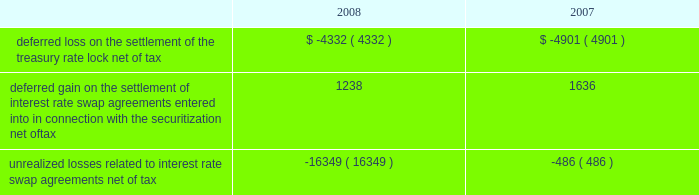American tower corporation and subsidiaries notes to consolidated financial statements 2014 ( continued ) of certain of its assets and liabilities under its interest rate swap agreements held as of december 31 , 2006 and entered into during the first half of 2007 .
In addition , the company paid $ 8.0 million related to a treasury rate lock agreement entered into and settled during the year ended december 31 , 2008 .
The cost of the treasury rate lock is being recognized as additional interest expense over the 10-year term of the 7.00% ( 7.00 % ) notes .
During the year ended december 31 , 2007 , the company also received $ 3.1 million in cash upon settlement of the assets and liabilities under ten forward starting interest rate swap agreements with an aggregate notional amount of $ 1.4 billion , which were designated as cash flow hedges to manage exposure to variability in cash flows relating to forecasted interest payments in connection with the certificates issued in the securitization in may 2007 .
The settlement is being recognized as a reduction in interest expense over the five-year period for which the interest rate swaps were designated as hedges .
The company also received $ 17.0 million in cash upon settlement of the assets and liabilities under thirteen additional interest rate swap agreements with an aggregate notional amount of $ 850.0 million that managed exposure to variability of interest rates under the credit facilities but were not considered cash flow hedges for accounting purposes .
This gain is included in other income in the accompanying consolidated statement of operations for the year ended december 31 , 2007 .
As of december 31 , 2008 and 2007 , other comprehensive ( loss ) income included the following items related to derivative financial instruments ( in thousands ) : .
During the years ended december 31 , 2008 and 2007 , the company recorded an aggregate net unrealized loss of approximately $ 15.8 million and $ 3.2 million , respectively ( net of a tax provision of approximately $ 10.2 million and $ 2.0 million , respectively ) in other comprehensive loss for the change in fair value of interest rate swaps designated as cash flow hedges and reclassified an aggregate of $ 0.1 million and $ 6.2 million , respectively ( net of an income tax provision of $ 2.0 million and an income tax benefit of $ 3.3 million , respectively ) into results of operations .
Fair valuemeasurements the company determines the fair market values of its financial instruments based on the fair value hierarchy established in sfas no .
157 , which requires an entity to maximize the use of observable inputs and minimize the use of unobservable inputs when measuring fair value .
The standard describes three levels of inputs that may be used to measure fair value .
Level 1 quoted prices in active markets for identical assets or liabilities that the company has the ability to access at the measurement date .
The company 2019s level 1 assets consist of available-for-sale securities traded on active markets as well as certain brazilian treasury securities that are highly liquid and are actively traded in over-the-counter markets .
Level 2 observable inputs other than level 1 prices , such as quoted prices for similar assets or liabilities ; quoted prices in markets that are not active ; or other inputs that are observable or can be corroborated by observable market data for substantially the full term of the assets or liabilities. .
What is the pre-tax aggregate net unrealized loss in 2007? 
Computations: (3.2 + 2.0)
Answer: 5.2. 